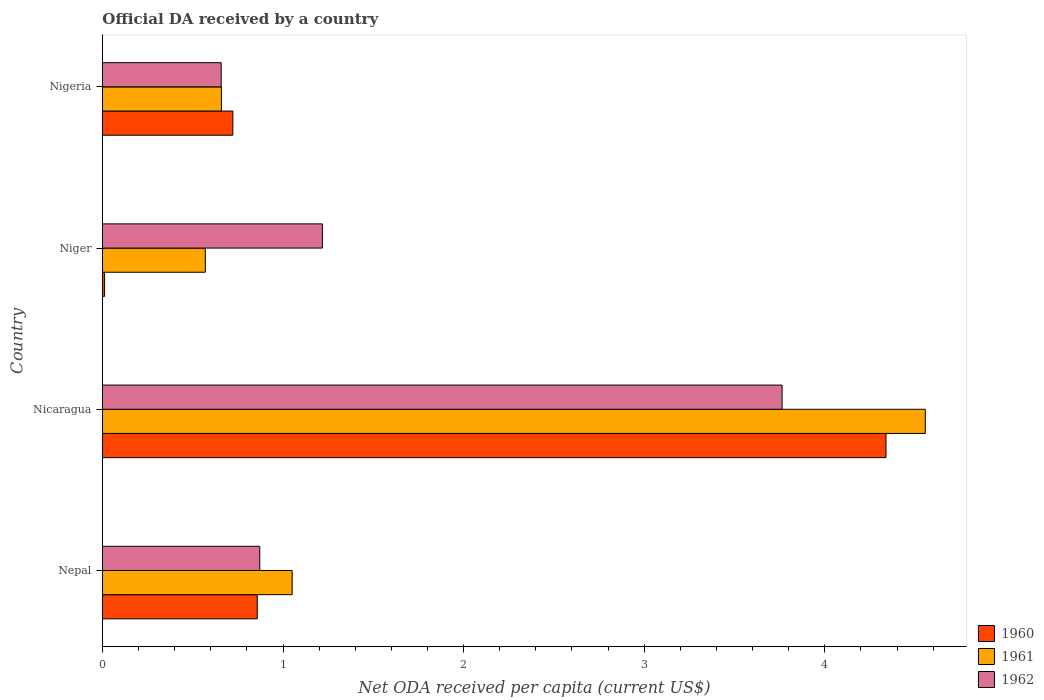How many different coloured bars are there?
Your answer should be very brief. 3. Are the number of bars on each tick of the Y-axis equal?
Your answer should be compact. Yes. What is the label of the 2nd group of bars from the top?
Keep it short and to the point. Niger. In how many cases, is the number of bars for a given country not equal to the number of legend labels?
Provide a short and direct response. 0. What is the ODA received in in 1962 in Nicaragua?
Offer a terse response. 3.76. Across all countries, what is the maximum ODA received in in 1962?
Your answer should be very brief. 3.76. Across all countries, what is the minimum ODA received in in 1961?
Give a very brief answer. 0.57. In which country was the ODA received in in 1962 maximum?
Give a very brief answer. Nicaragua. In which country was the ODA received in in 1960 minimum?
Provide a short and direct response. Niger. What is the total ODA received in in 1960 in the graph?
Your answer should be very brief. 5.93. What is the difference between the ODA received in in 1961 in Nepal and that in Nicaragua?
Your answer should be very brief. -3.51. What is the difference between the ODA received in in 1961 in Nicaragua and the ODA received in in 1960 in Nepal?
Keep it short and to the point. 3.7. What is the average ODA received in in 1960 per country?
Provide a succinct answer. 1.48. What is the difference between the ODA received in in 1960 and ODA received in in 1962 in Nepal?
Offer a very short reply. -0.01. What is the ratio of the ODA received in in 1962 in Nepal to that in Nicaragua?
Your response must be concise. 0.23. Is the ODA received in in 1960 in Nepal less than that in Niger?
Offer a very short reply. No. What is the difference between the highest and the second highest ODA received in in 1962?
Offer a terse response. 2.55. What is the difference between the highest and the lowest ODA received in in 1960?
Ensure brevity in your answer.  4.33. Is the sum of the ODA received in in 1961 in Nepal and Nicaragua greater than the maximum ODA received in in 1962 across all countries?
Ensure brevity in your answer.  Yes. Are all the bars in the graph horizontal?
Offer a very short reply. Yes. What is the difference between two consecutive major ticks on the X-axis?
Give a very brief answer. 1. Does the graph contain any zero values?
Your answer should be compact. No. How many legend labels are there?
Your answer should be very brief. 3. What is the title of the graph?
Your answer should be very brief. Official DA received by a country. What is the label or title of the X-axis?
Your response must be concise. Net ODA received per capita (current US$). What is the Net ODA received per capita (current US$) in 1960 in Nepal?
Your response must be concise. 0.86. What is the Net ODA received per capita (current US$) in 1961 in Nepal?
Provide a short and direct response. 1.05. What is the Net ODA received per capita (current US$) of 1962 in Nepal?
Your response must be concise. 0.87. What is the Net ODA received per capita (current US$) in 1960 in Nicaragua?
Ensure brevity in your answer.  4.34. What is the Net ODA received per capita (current US$) in 1961 in Nicaragua?
Provide a succinct answer. 4.56. What is the Net ODA received per capita (current US$) in 1962 in Nicaragua?
Make the answer very short. 3.76. What is the Net ODA received per capita (current US$) in 1960 in Niger?
Give a very brief answer. 0.01. What is the Net ODA received per capita (current US$) in 1961 in Niger?
Provide a short and direct response. 0.57. What is the Net ODA received per capita (current US$) in 1962 in Niger?
Offer a terse response. 1.22. What is the Net ODA received per capita (current US$) of 1960 in Nigeria?
Make the answer very short. 0.72. What is the Net ODA received per capita (current US$) of 1961 in Nigeria?
Provide a short and direct response. 0.66. What is the Net ODA received per capita (current US$) of 1962 in Nigeria?
Your answer should be compact. 0.66. Across all countries, what is the maximum Net ODA received per capita (current US$) of 1960?
Keep it short and to the point. 4.34. Across all countries, what is the maximum Net ODA received per capita (current US$) of 1961?
Offer a very short reply. 4.56. Across all countries, what is the maximum Net ODA received per capita (current US$) in 1962?
Give a very brief answer. 3.76. Across all countries, what is the minimum Net ODA received per capita (current US$) of 1960?
Ensure brevity in your answer.  0.01. Across all countries, what is the minimum Net ODA received per capita (current US$) in 1961?
Your response must be concise. 0.57. Across all countries, what is the minimum Net ODA received per capita (current US$) in 1962?
Your response must be concise. 0.66. What is the total Net ODA received per capita (current US$) of 1960 in the graph?
Ensure brevity in your answer.  5.93. What is the total Net ODA received per capita (current US$) of 1961 in the graph?
Give a very brief answer. 6.83. What is the total Net ODA received per capita (current US$) of 1962 in the graph?
Keep it short and to the point. 6.51. What is the difference between the Net ODA received per capita (current US$) of 1960 in Nepal and that in Nicaragua?
Your answer should be very brief. -3.48. What is the difference between the Net ODA received per capita (current US$) of 1961 in Nepal and that in Nicaragua?
Give a very brief answer. -3.51. What is the difference between the Net ODA received per capita (current US$) in 1962 in Nepal and that in Nicaragua?
Provide a succinct answer. -2.89. What is the difference between the Net ODA received per capita (current US$) in 1960 in Nepal and that in Niger?
Make the answer very short. 0.85. What is the difference between the Net ODA received per capita (current US$) of 1961 in Nepal and that in Niger?
Offer a terse response. 0.48. What is the difference between the Net ODA received per capita (current US$) in 1962 in Nepal and that in Niger?
Your answer should be compact. -0.35. What is the difference between the Net ODA received per capita (current US$) of 1960 in Nepal and that in Nigeria?
Your answer should be very brief. 0.14. What is the difference between the Net ODA received per capita (current US$) of 1961 in Nepal and that in Nigeria?
Your response must be concise. 0.39. What is the difference between the Net ODA received per capita (current US$) in 1962 in Nepal and that in Nigeria?
Your answer should be very brief. 0.21. What is the difference between the Net ODA received per capita (current US$) in 1960 in Nicaragua and that in Niger?
Provide a succinct answer. 4.33. What is the difference between the Net ODA received per capita (current US$) in 1961 in Nicaragua and that in Niger?
Your answer should be very brief. 3.99. What is the difference between the Net ODA received per capita (current US$) of 1962 in Nicaragua and that in Niger?
Your answer should be very brief. 2.55. What is the difference between the Net ODA received per capita (current US$) in 1960 in Nicaragua and that in Nigeria?
Give a very brief answer. 3.62. What is the difference between the Net ODA received per capita (current US$) of 1961 in Nicaragua and that in Nigeria?
Your answer should be compact. 3.9. What is the difference between the Net ODA received per capita (current US$) in 1962 in Nicaragua and that in Nigeria?
Give a very brief answer. 3.11. What is the difference between the Net ODA received per capita (current US$) in 1960 in Niger and that in Nigeria?
Ensure brevity in your answer.  -0.71. What is the difference between the Net ODA received per capita (current US$) in 1961 in Niger and that in Nigeria?
Your answer should be compact. -0.09. What is the difference between the Net ODA received per capita (current US$) in 1962 in Niger and that in Nigeria?
Provide a succinct answer. 0.56. What is the difference between the Net ODA received per capita (current US$) in 1960 in Nepal and the Net ODA received per capita (current US$) in 1961 in Nicaragua?
Your answer should be compact. -3.7. What is the difference between the Net ODA received per capita (current US$) in 1960 in Nepal and the Net ODA received per capita (current US$) in 1962 in Nicaragua?
Make the answer very short. -2.91. What is the difference between the Net ODA received per capita (current US$) in 1961 in Nepal and the Net ODA received per capita (current US$) in 1962 in Nicaragua?
Your answer should be very brief. -2.71. What is the difference between the Net ODA received per capita (current US$) in 1960 in Nepal and the Net ODA received per capita (current US$) in 1961 in Niger?
Provide a short and direct response. 0.29. What is the difference between the Net ODA received per capita (current US$) in 1960 in Nepal and the Net ODA received per capita (current US$) in 1962 in Niger?
Give a very brief answer. -0.36. What is the difference between the Net ODA received per capita (current US$) of 1961 in Nepal and the Net ODA received per capita (current US$) of 1962 in Niger?
Provide a succinct answer. -0.17. What is the difference between the Net ODA received per capita (current US$) of 1960 in Nepal and the Net ODA received per capita (current US$) of 1961 in Nigeria?
Your response must be concise. 0.2. What is the difference between the Net ODA received per capita (current US$) in 1960 in Nepal and the Net ODA received per capita (current US$) in 1962 in Nigeria?
Your answer should be very brief. 0.2. What is the difference between the Net ODA received per capita (current US$) of 1961 in Nepal and the Net ODA received per capita (current US$) of 1962 in Nigeria?
Offer a very short reply. 0.39. What is the difference between the Net ODA received per capita (current US$) in 1960 in Nicaragua and the Net ODA received per capita (current US$) in 1961 in Niger?
Give a very brief answer. 3.77. What is the difference between the Net ODA received per capita (current US$) in 1960 in Nicaragua and the Net ODA received per capita (current US$) in 1962 in Niger?
Make the answer very short. 3.12. What is the difference between the Net ODA received per capita (current US$) in 1961 in Nicaragua and the Net ODA received per capita (current US$) in 1962 in Niger?
Keep it short and to the point. 3.34. What is the difference between the Net ODA received per capita (current US$) of 1960 in Nicaragua and the Net ODA received per capita (current US$) of 1961 in Nigeria?
Your answer should be compact. 3.68. What is the difference between the Net ODA received per capita (current US$) of 1960 in Nicaragua and the Net ODA received per capita (current US$) of 1962 in Nigeria?
Make the answer very short. 3.68. What is the difference between the Net ODA received per capita (current US$) of 1961 in Nicaragua and the Net ODA received per capita (current US$) of 1962 in Nigeria?
Keep it short and to the point. 3.9. What is the difference between the Net ODA received per capita (current US$) of 1960 in Niger and the Net ODA received per capita (current US$) of 1961 in Nigeria?
Offer a terse response. -0.65. What is the difference between the Net ODA received per capita (current US$) in 1960 in Niger and the Net ODA received per capita (current US$) in 1962 in Nigeria?
Provide a succinct answer. -0.65. What is the difference between the Net ODA received per capita (current US$) of 1961 in Niger and the Net ODA received per capita (current US$) of 1962 in Nigeria?
Offer a terse response. -0.09. What is the average Net ODA received per capita (current US$) in 1960 per country?
Give a very brief answer. 1.48. What is the average Net ODA received per capita (current US$) of 1961 per country?
Ensure brevity in your answer.  1.71. What is the average Net ODA received per capita (current US$) of 1962 per country?
Ensure brevity in your answer.  1.63. What is the difference between the Net ODA received per capita (current US$) in 1960 and Net ODA received per capita (current US$) in 1961 in Nepal?
Provide a succinct answer. -0.19. What is the difference between the Net ODA received per capita (current US$) of 1960 and Net ODA received per capita (current US$) of 1962 in Nepal?
Provide a succinct answer. -0.01. What is the difference between the Net ODA received per capita (current US$) of 1961 and Net ODA received per capita (current US$) of 1962 in Nepal?
Provide a short and direct response. 0.18. What is the difference between the Net ODA received per capita (current US$) in 1960 and Net ODA received per capita (current US$) in 1961 in Nicaragua?
Your answer should be compact. -0.22. What is the difference between the Net ODA received per capita (current US$) in 1960 and Net ODA received per capita (current US$) in 1962 in Nicaragua?
Provide a succinct answer. 0.58. What is the difference between the Net ODA received per capita (current US$) in 1961 and Net ODA received per capita (current US$) in 1962 in Nicaragua?
Offer a terse response. 0.79. What is the difference between the Net ODA received per capita (current US$) in 1960 and Net ODA received per capita (current US$) in 1961 in Niger?
Keep it short and to the point. -0.56. What is the difference between the Net ODA received per capita (current US$) in 1960 and Net ODA received per capita (current US$) in 1962 in Niger?
Keep it short and to the point. -1.21. What is the difference between the Net ODA received per capita (current US$) in 1961 and Net ODA received per capita (current US$) in 1962 in Niger?
Your response must be concise. -0.65. What is the difference between the Net ODA received per capita (current US$) of 1960 and Net ODA received per capita (current US$) of 1961 in Nigeria?
Your answer should be compact. 0.06. What is the difference between the Net ODA received per capita (current US$) in 1960 and Net ODA received per capita (current US$) in 1962 in Nigeria?
Ensure brevity in your answer.  0.06. What is the difference between the Net ODA received per capita (current US$) in 1961 and Net ODA received per capita (current US$) in 1962 in Nigeria?
Provide a short and direct response. 0. What is the ratio of the Net ODA received per capita (current US$) in 1960 in Nepal to that in Nicaragua?
Your answer should be very brief. 0.2. What is the ratio of the Net ODA received per capita (current US$) of 1961 in Nepal to that in Nicaragua?
Give a very brief answer. 0.23. What is the ratio of the Net ODA received per capita (current US$) in 1962 in Nepal to that in Nicaragua?
Your response must be concise. 0.23. What is the ratio of the Net ODA received per capita (current US$) in 1960 in Nepal to that in Niger?
Keep it short and to the point. 72.75. What is the ratio of the Net ODA received per capita (current US$) in 1961 in Nepal to that in Niger?
Your answer should be very brief. 1.84. What is the ratio of the Net ODA received per capita (current US$) in 1962 in Nepal to that in Niger?
Your response must be concise. 0.72. What is the ratio of the Net ODA received per capita (current US$) of 1960 in Nepal to that in Nigeria?
Ensure brevity in your answer.  1.19. What is the ratio of the Net ODA received per capita (current US$) in 1961 in Nepal to that in Nigeria?
Give a very brief answer. 1.59. What is the ratio of the Net ODA received per capita (current US$) of 1962 in Nepal to that in Nigeria?
Offer a very short reply. 1.32. What is the ratio of the Net ODA received per capita (current US$) of 1960 in Nicaragua to that in Niger?
Offer a very short reply. 368.28. What is the ratio of the Net ODA received per capita (current US$) in 1961 in Nicaragua to that in Niger?
Ensure brevity in your answer.  8. What is the ratio of the Net ODA received per capita (current US$) in 1962 in Nicaragua to that in Niger?
Offer a very short reply. 3.09. What is the ratio of the Net ODA received per capita (current US$) of 1960 in Nicaragua to that in Nigeria?
Offer a very short reply. 6.01. What is the ratio of the Net ODA received per capita (current US$) in 1961 in Nicaragua to that in Nigeria?
Provide a succinct answer. 6.92. What is the ratio of the Net ODA received per capita (current US$) of 1962 in Nicaragua to that in Nigeria?
Ensure brevity in your answer.  5.72. What is the ratio of the Net ODA received per capita (current US$) in 1960 in Niger to that in Nigeria?
Make the answer very short. 0.02. What is the ratio of the Net ODA received per capita (current US$) of 1961 in Niger to that in Nigeria?
Give a very brief answer. 0.86. What is the ratio of the Net ODA received per capita (current US$) of 1962 in Niger to that in Nigeria?
Make the answer very short. 1.85. What is the difference between the highest and the second highest Net ODA received per capita (current US$) in 1960?
Give a very brief answer. 3.48. What is the difference between the highest and the second highest Net ODA received per capita (current US$) in 1961?
Provide a succinct answer. 3.51. What is the difference between the highest and the second highest Net ODA received per capita (current US$) in 1962?
Your response must be concise. 2.55. What is the difference between the highest and the lowest Net ODA received per capita (current US$) of 1960?
Your response must be concise. 4.33. What is the difference between the highest and the lowest Net ODA received per capita (current US$) in 1961?
Your answer should be very brief. 3.99. What is the difference between the highest and the lowest Net ODA received per capita (current US$) of 1962?
Provide a short and direct response. 3.11. 